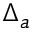<formula> <loc_0><loc_0><loc_500><loc_500>\Delta _ { a }</formula> 